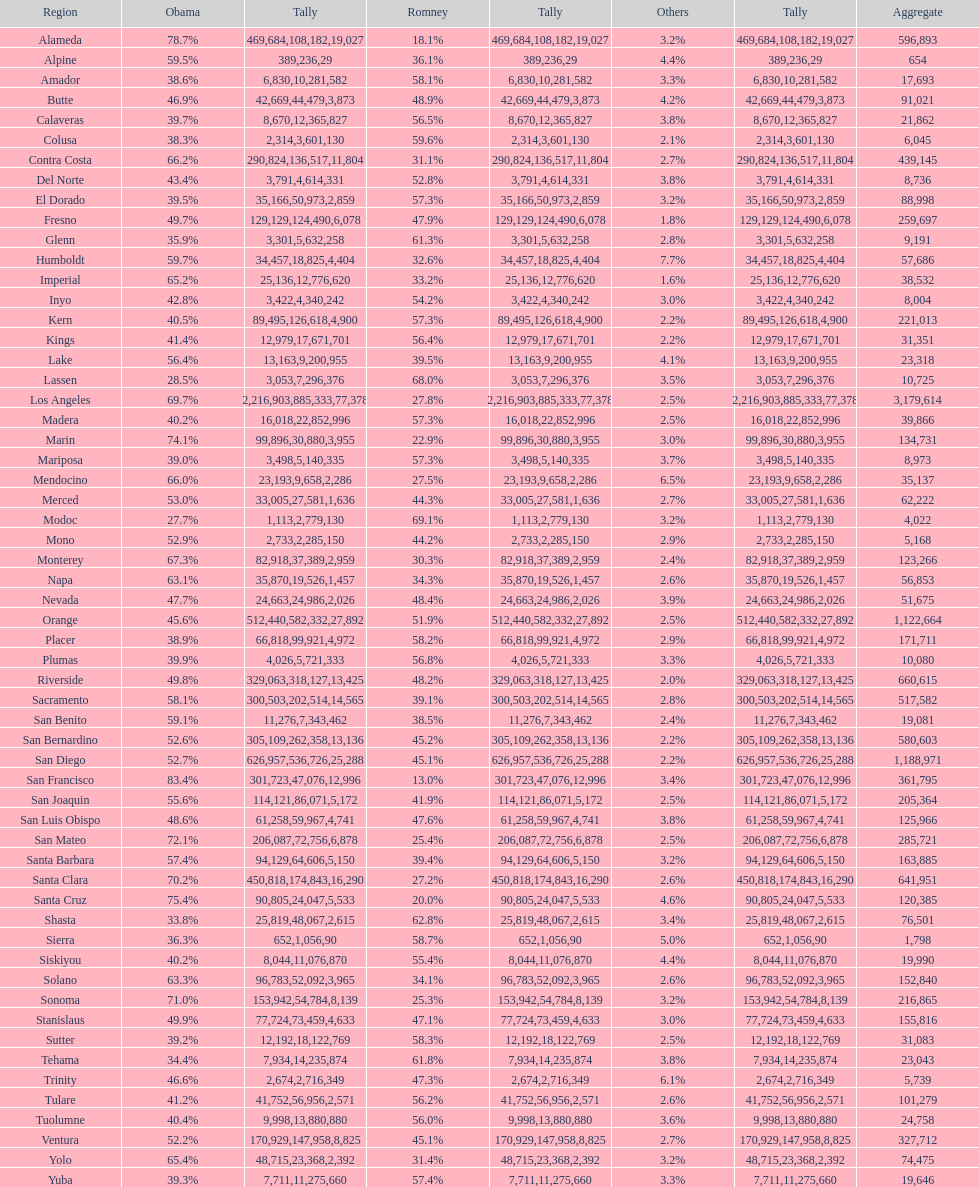Did romney earn more or less votes than obama did in alameda county? Less. 